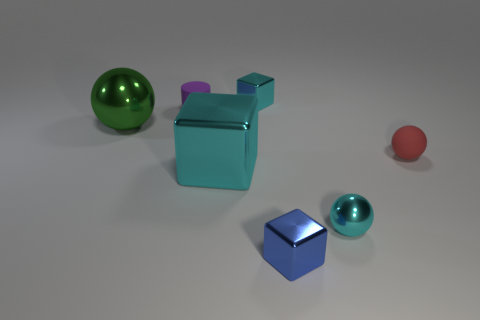Which object in this image is the largest? The largest object appears to be the green spherical object towards the left side of the image. 